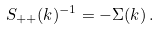<formula> <loc_0><loc_0><loc_500><loc_500>S _ { + + } ( k ) ^ { - 1 } = - \Sigma ( k ) \, .</formula> 